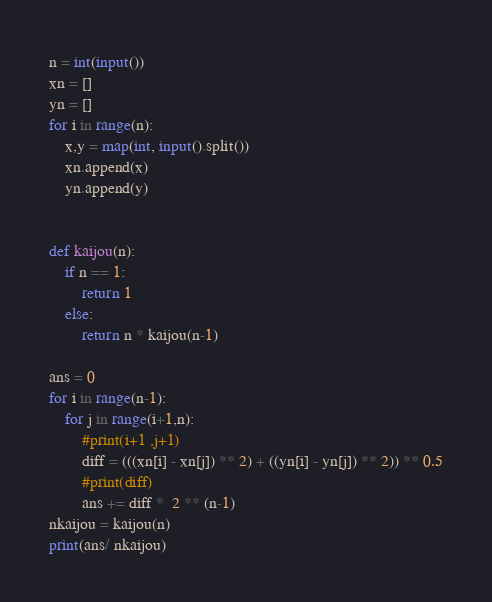<code> <loc_0><loc_0><loc_500><loc_500><_Python_>n = int(input())
xn = []
yn = []
for i in range(n):
    x,y = map(int, input().split())
    xn.append(x)
    yn.append(y)
    
    
def kaijou(n):
    if n == 1:
        return 1
    else:
        return n * kaijou(n-1)
    
ans = 0
for i in range(n-1):
    for j in range(i+1,n):
        #print(i+1 ,j+1)
        diff = (((xn[i] - xn[j]) ** 2) + ((yn[i] - yn[j]) ** 2)) ** 0.5
        #print(diff)
        ans += diff *  2 ** (n-1)
nkaijou = kaijou(n)
print(ans/ nkaijou)</code> 